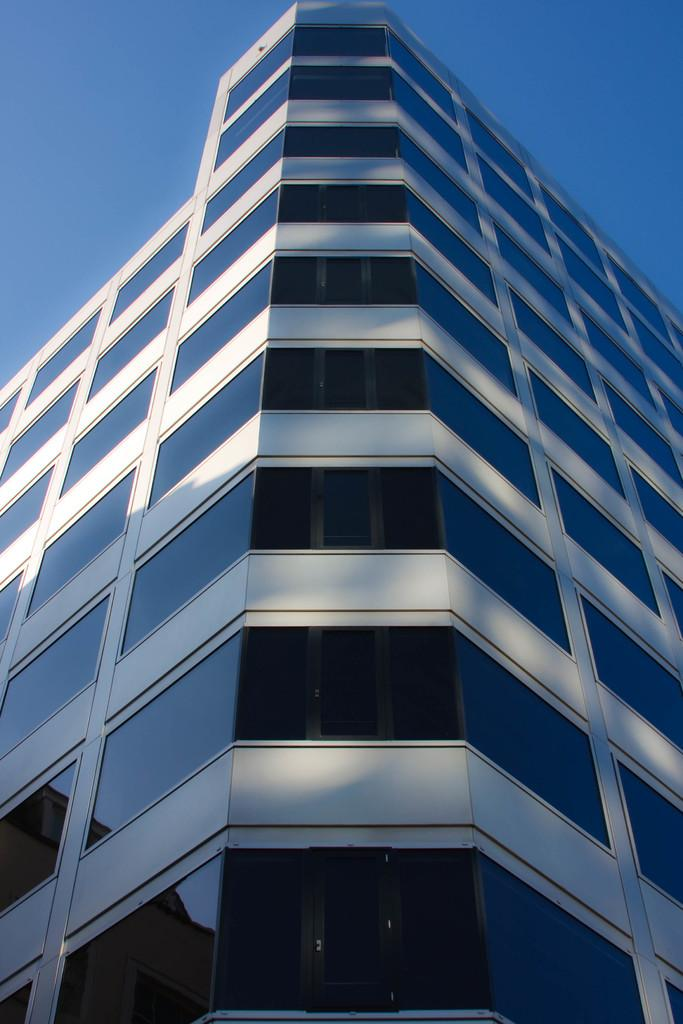What is the main structure in the image? There is a building in the image. What is covering the building? The building is covered with glasses. What can be seen in the background of the image? The sky is visible in the background of the image. What type of advice can be seen written on the building in the image? There is no advice visible on the building in the image; it is covered with glasses. Can you point out the crack on the building in the image? There is no crack visible on the building in the image; it is covered with glasses. 